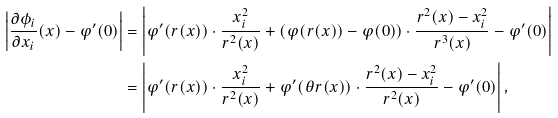<formula> <loc_0><loc_0><loc_500><loc_500>\left | \frac { \partial \phi _ { i } } { \partial x _ { i } } ( x ) - \varphi ^ { \prime } ( 0 ) \right | & = \left | \varphi ^ { \prime } ( r ( x ) ) \cdot \frac { x _ { i } ^ { 2 } } { r ^ { 2 } ( x ) } + ( \varphi ( r ( x ) ) - \varphi ( 0 ) ) \cdot \frac { r ^ { 2 } ( x ) - x _ { i } ^ { 2 } } { r ^ { 3 } ( x ) } - \varphi ^ { \prime } ( 0 ) \right | \\ & = \left | \varphi ^ { \prime } ( r ( x ) ) \cdot \frac { x _ { i } ^ { 2 } } { r ^ { 2 } ( x ) } + \varphi ^ { \prime } ( \theta r ( x ) ) \cdot \frac { r ^ { 2 } ( x ) - x _ { i } ^ { 2 } } { r ^ { 2 } ( x ) } - \varphi ^ { \prime } ( 0 ) \right | ,</formula> 